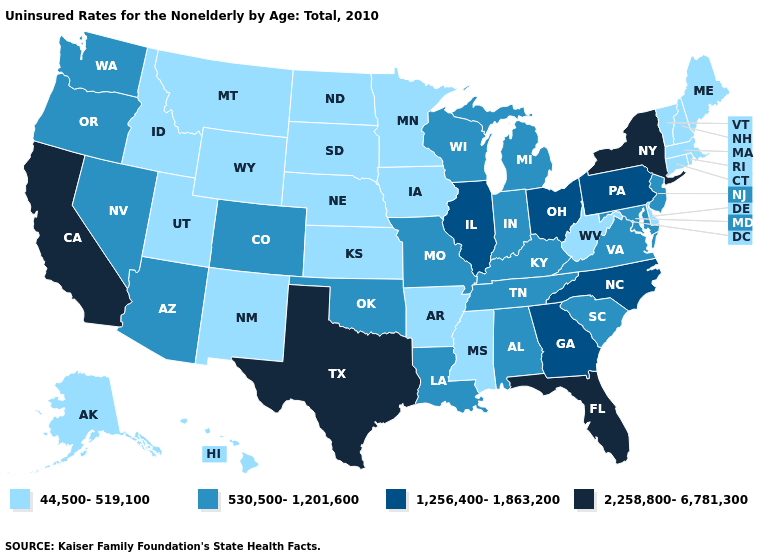What is the highest value in the USA?
Be succinct. 2,258,800-6,781,300. Name the states that have a value in the range 1,256,400-1,863,200?
Quick response, please. Georgia, Illinois, North Carolina, Ohio, Pennsylvania. Which states hav the highest value in the Northeast?
Concise answer only. New York. Name the states that have a value in the range 44,500-519,100?
Be succinct. Alaska, Arkansas, Connecticut, Delaware, Hawaii, Idaho, Iowa, Kansas, Maine, Massachusetts, Minnesota, Mississippi, Montana, Nebraska, New Hampshire, New Mexico, North Dakota, Rhode Island, South Dakota, Utah, Vermont, West Virginia, Wyoming. Does Connecticut have the highest value in the Northeast?
Write a very short answer. No. What is the value of Rhode Island?
Concise answer only. 44,500-519,100. What is the highest value in states that border Washington?
Quick response, please. 530,500-1,201,600. What is the value of Connecticut?
Answer briefly. 44,500-519,100. What is the value of Ohio?
Keep it brief. 1,256,400-1,863,200. Which states have the lowest value in the USA?
Concise answer only. Alaska, Arkansas, Connecticut, Delaware, Hawaii, Idaho, Iowa, Kansas, Maine, Massachusetts, Minnesota, Mississippi, Montana, Nebraska, New Hampshire, New Mexico, North Dakota, Rhode Island, South Dakota, Utah, Vermont, West Virginia, Wyoming. Name the states that have a value in the range 530,500-1,201,600?
Write a very short answer. Alabama, Arizona, Colorado, Indiana, Kentucky, Louisiana, Maryland, Michigan, Missouri, Nevada, New Jersey, Oklahoma, Oregon, South Carolina, Tennessee, Virginia, Washington, Wisconsin. Does Oregon have the same value as Texas?
Keep it brief. No. What is the value of Ohio?
Keep it brief. 1,256,400-1,863,200. Among the states that border North Dakota , which have the lowest value?
Concise answer only. Minnesota, Montana, South Dakota. Which states have the highest value in the USA?
Write a very short answer. California, Florida, New York, Texas. 